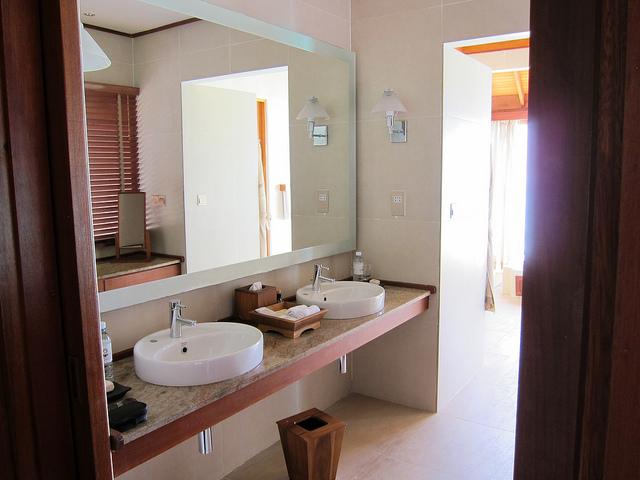Is the light turned on?
Keep it brief. No. Is the sink made out of porcelain?
Write a very short answer. Yes. What material is the waste basket made of?
Be succinct. Wood. What's about the outlet on the wall?
Quick response, please. Light. 